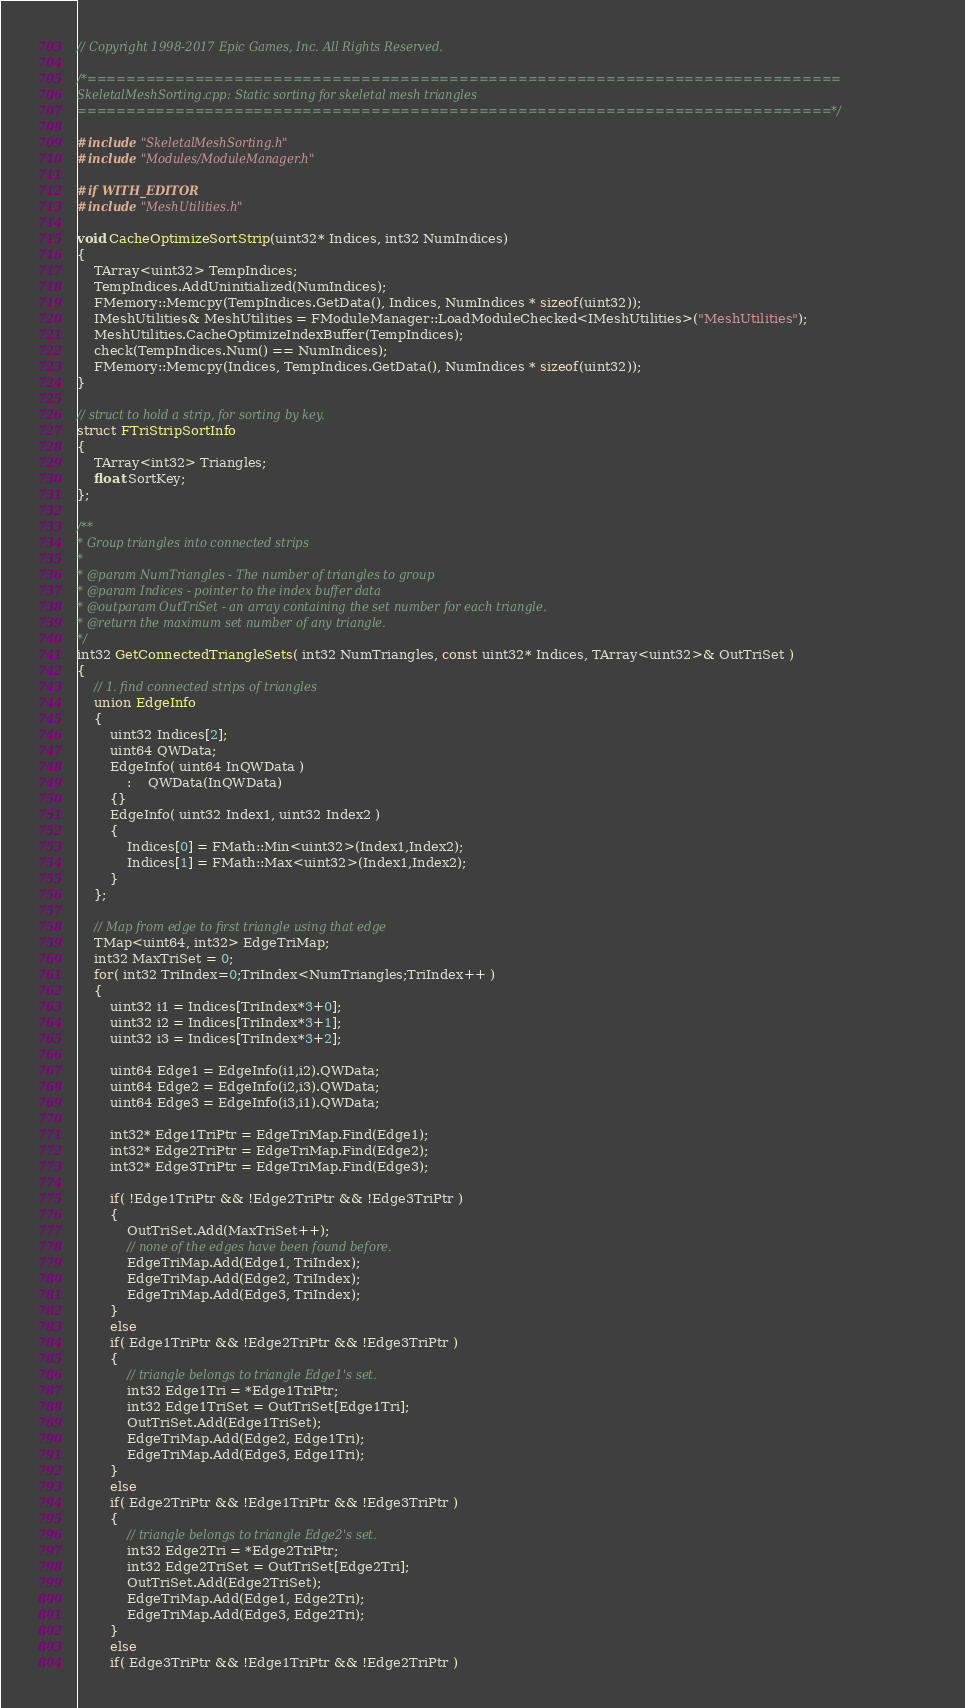Convert code to text. <code><loc_0><loc_0><loc_500><loc_500><_C++_>// Copyright 1998-2017 Epic Games, Inc. All Rights Reserved.

/*=============================================================================
SkeletalMeshSorting.cpp: Static sorting for skeletal mesh triangles
=============================================================================*/

#include "SkeletalMeshSorting.h"
#include "Modules/ModuleManager.h"

#if WITH_EDITOR
#include "MeshUtilities.h"

void CacheOptimizeSortStrip(uint32* Indices, int32 NumIndices)
{
	TArray<uint32> TempIndices;
	TempIndices.AddUninitialized(NumIndices);
	FMemory::Memcpy(TempIndices.GetData(), Indices, NumIndices * sizeof(uint32));
	IMeshUtilities& MeshUtilities = FModuleManager::LoadModuleChecked<IMeshUtilities>("MeshUtilities");
	MeshUtilities.CacheOptimizeIndexBuffer(TempIndices);
	check(TempIndices.Num() == NumIndices);
	FMemory::Memcpy(Indices, TempIndices.GetData(), NumIndices * sizeof(uint32));
}

// struct to hold a strip, for sorting by key.
struct FTriStripSortInfo
{
	TArray<int32> Triangles;
	float SortKey;
};

/**
* Group triangles into connected strips 
*
* @param NumTriangles - The number of triangles to group
* @param Indices - pointer to the index buffer data
* @outparam OutTriSet - an array containing the set number for each triangle.
* @return the maximum set number of any triangle.
*/
int32 GetConnectedTriangleSets( int32 NumTriangles, const uint32* Indices, TArray<uint32>& OutTriSet )
{
	// 1. find connected strips of triangles
	union EdgeInfo
	{		
		uint32 Indices[2];
		uint64 QWData;
		EdgeInfo( uint64 InQWData )
			:	QWData(InQWData)
		{}
		EdgeInfo( uint32 Index1, uint32 Index2 )
		{
			Indices[0] = FMath::Min<uint32>(Index1,Index2);
			Indices[1] = FMath::Max<uint32>(Index1,Index2);
		}
	};

	// Map from edge to first triangle using that edge
	TMap<uint64, int32> EdgeTriMap;
	int32 MaxTriSet = 0;
	for( int32 TriIndex=0;TriIndex<NumTriangles;TriIndex++ )
	{
		uint32 i1 = Indices[TriIndex*3+0];
		uint32 i2 = Indices[TriIndex*3+1];
		uint32 i3 = Indices[TriIndex*3+2];

		uint64 Edge1 = EdgeInfo(i1,i2).QWData;
		uint64 Edge2 = EdgeInfo(i2,i3).QWData;
		uint64 Edge3 = EdgeInfo(i3,i1).QWData;

		int32* Edge1TriPtr = EdgeTriMap.Find(Edge1);
		int32* Edge2TriPtr = EdgeTriMap.Find(Edge2);
		int32* Edge3TriPtr = EdgeTriMap.Find(Edge3);

		if( !Edge1TriPtr && !Edge2TriPtr && !Edge3TriPtr )
		{
			OutTriSet.Add(MaxTriSet++);
			// none of the edges have been found before.
			EdgeTriMap.Add(Edge1, TriIndex);
			EdgeTriMap.Add(Edge2, TriIndex);
			EdgeTriMap.Add(Edge3, TriIndex);
		}
		else
		if( Edge1TriPtr && !Edge2TriPtr && !Edge3TriPtr )
		{
			// triangle belongs to triangle Edge1's set.
			int32 Edge1Tri = *Edge1TriPtr;
			int32 Edge1TriSet = OutTriSet[Edge1Tri];
			OutTriSet.Add(Edge1TriSet);
			EdgeTriMap.Add(Edge2, Edge1Tri);
			EdgeTriMap.Add(Edge3, Edge1Tri);
		}
		else
		if( Edge2TriPtr && !Edge1TriPtr && !Edge3TriPtr )
		{
			// triangle belongs to triangle Edge2's set.
			int32 Edge2Tri = *Edge2TriPtr;
			int32 Edge2TriSet = OutTriSet[Edge2Tri];
			OutTriSet.Add(Edge2TriSet);
			EdgeTriMap.Add(Edge1, Edge2Tri);
			EdgeTriMap.Add(Edge3, Edge2Tri);
		}
		else
		if( Edge3TriPtr && !Edge1TriPtr && !Edge2TriPtr )</code> 